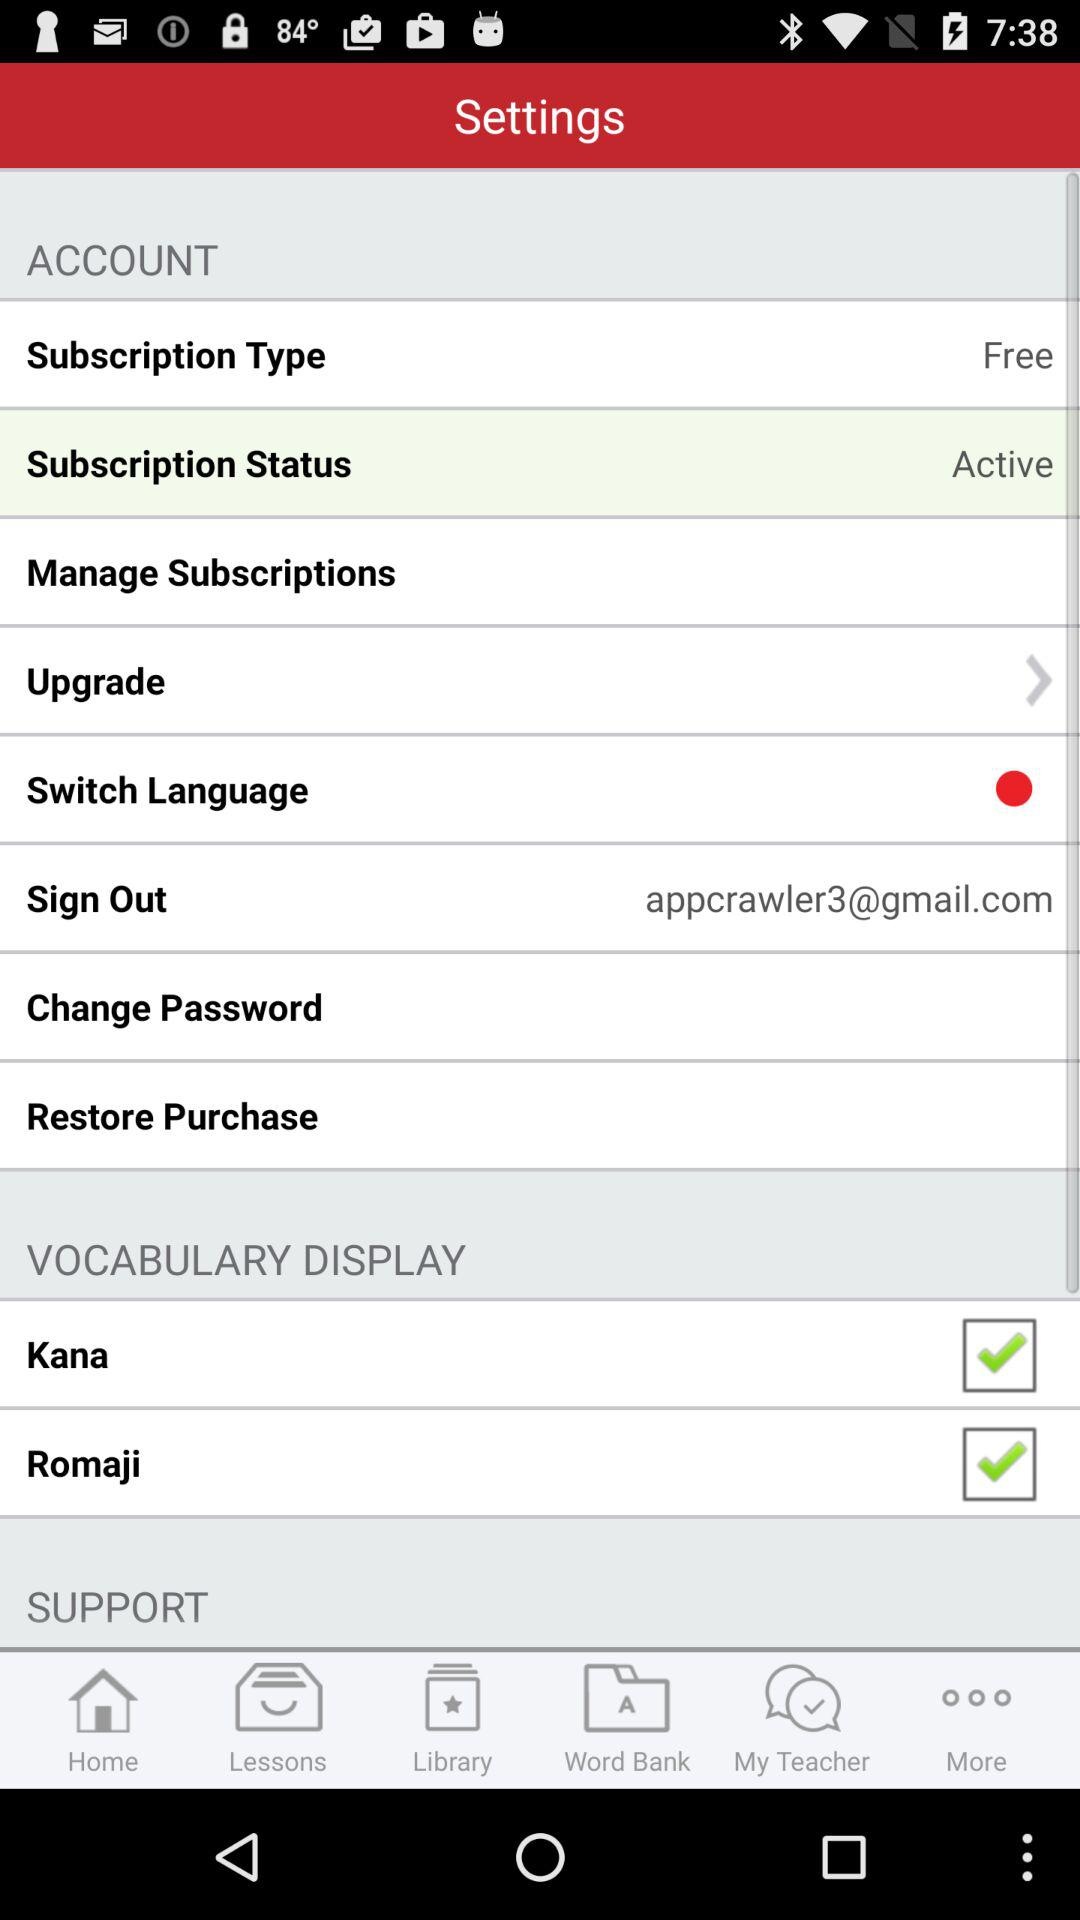What is the subscription status? The subscription status is active. 